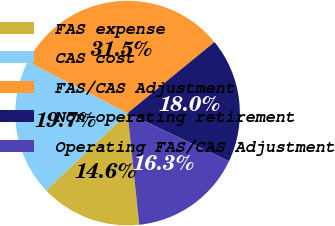Convert chart to OTSL. <chart><loc_0><loc_0><loc_500><loc_500><pie_chart><fcel>FAS expense<fcel>CAS cost<fcel>FAS/CAS Adjustment<fcel>Non-operating retirement<fcel>Operating FAS/CAS Adjustment<nl><fcel>14.58%<fcel>19.66%<fcel>31.51%<fcel>17.97%<fcel>16.28%<nl></chart> 